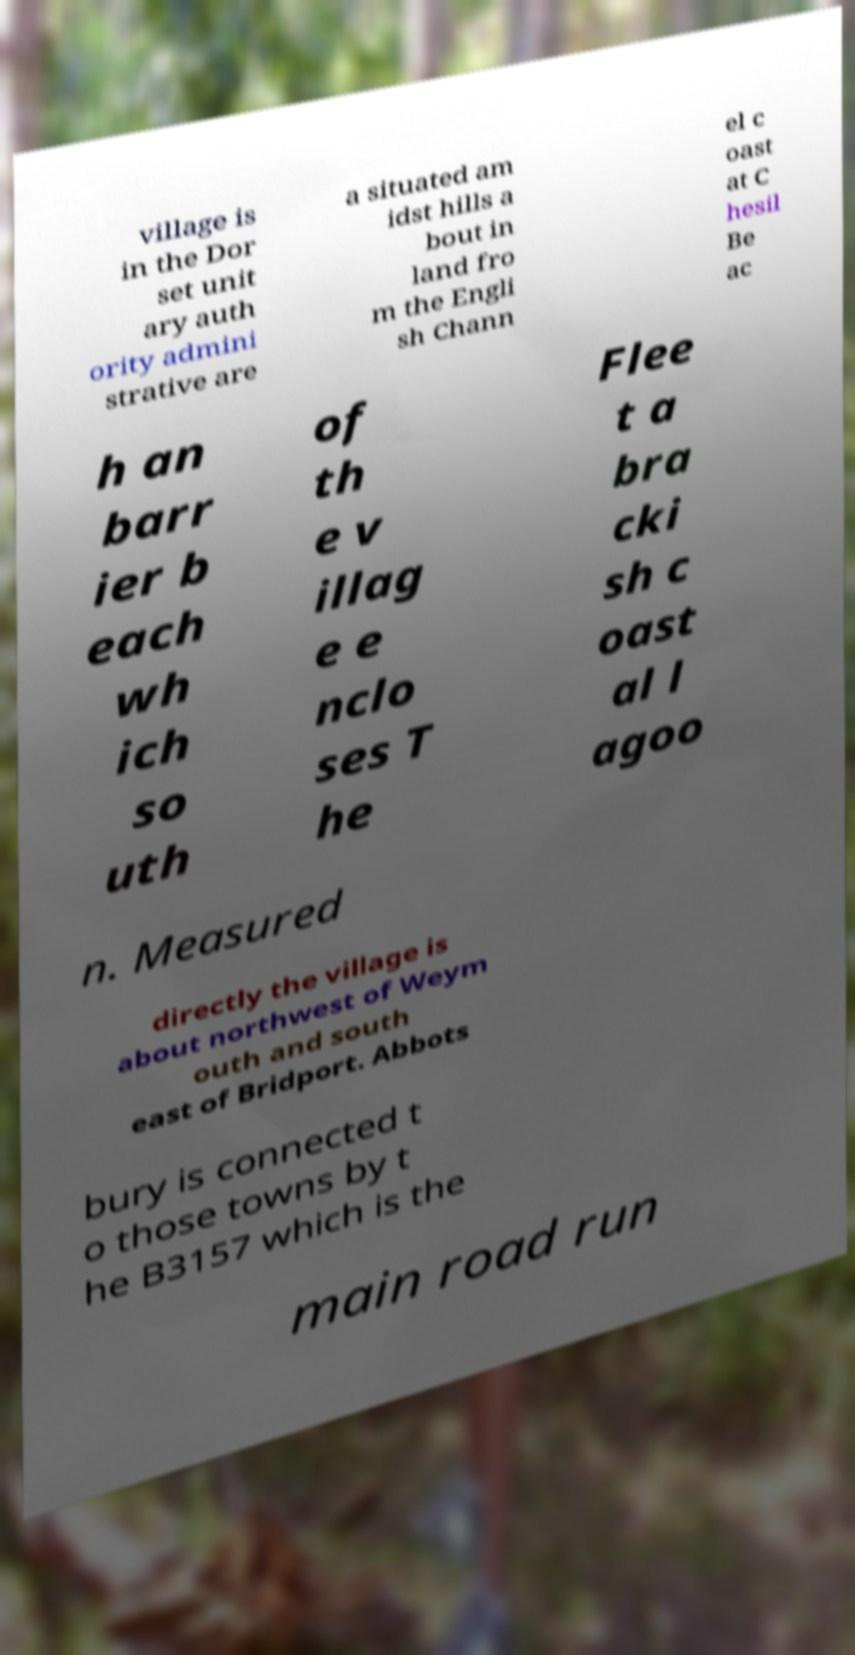What messages or text are displayed in this image? I need them in a readable, typed format. village is in the Dor set unit ary auth ority admini strative are a situated am idst hills a bout in land fro m the Engli sh Chann el c oast at C hesil Be ac h an barr ier b each wh ich so uth of th e v illag e e nclo ses T he Flee t a bra cki sh c oast al l agoo n. Measured directly the village is about northwest of Weym outh and south east of Bridport. Abbots bury is connected t o those towns by t he B3157 which is the main road run 